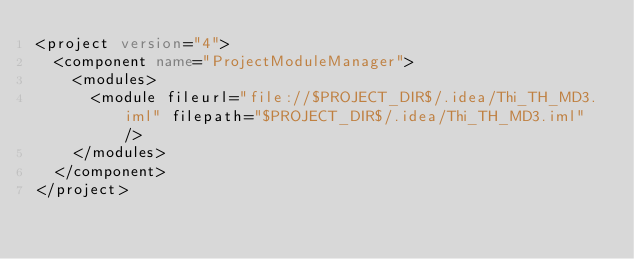Convert code to text. <code><loc_0><loc_0><loc_500><loc_500><_XML_><project version="4">
  <component name="ProjectModuleManager">
    <modules>
      <module fileurl="file://$PROJECT_DIR$/.idea/Thi_TH_MD3.iml" filepath="$PROJECT_DIR$/.idea/Thi_TH_MD3.iml" />
    </modules>
  </component>
</project></code> 